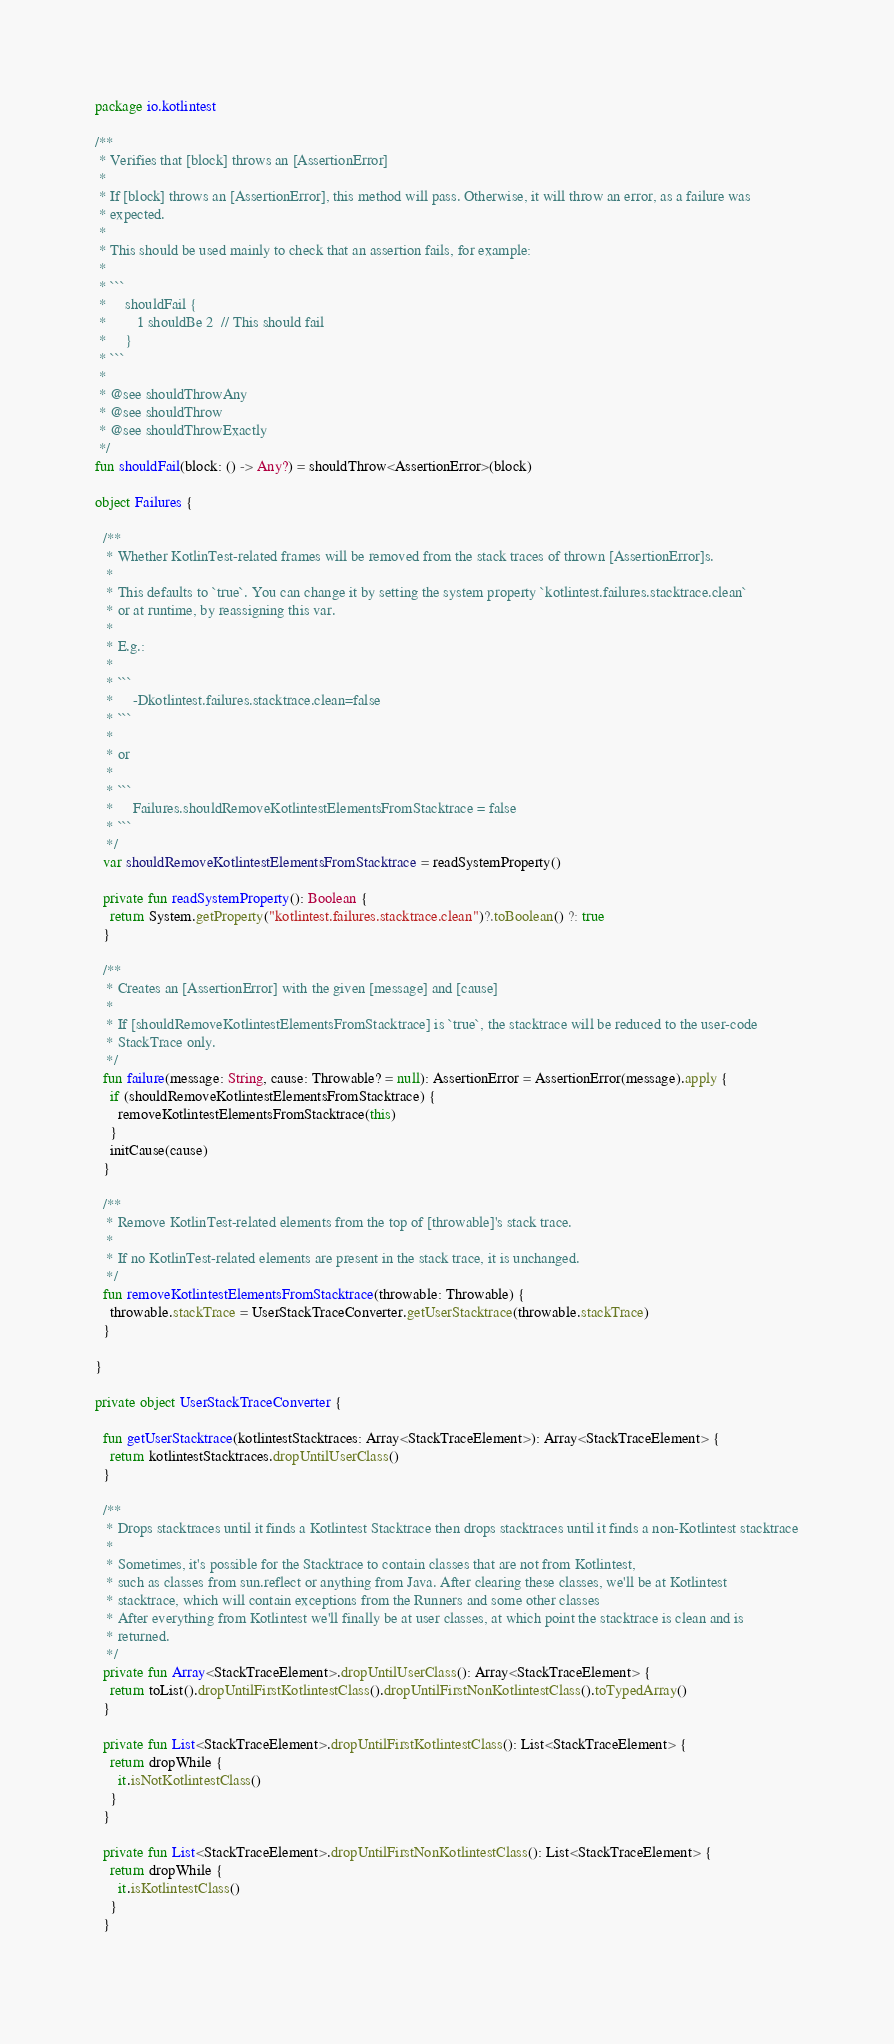<code> <loc_0><loc_0><loc_500><loc_500><_Kotlin_>package io.kotlintest

/**
 * Verifies that [block] throws an [AssertionError]
 *
 * If [block] throws an [AssertionError], this method will pass. Otherwise, it will throw an error, as a failure was
 * expected.
 *
 * This should be used mainly to check that an assertion fails, for example:
 *
 * ```
 *     shouldFail {
 *        1 shouldBe 2  // This should fail
 *     }
 * ```
 *
 * @see shouldThrowAny
 * @see shouldThrow
 * @see shouldThrowExactly
 */
fun shouldFail(block: () -> Any?) = shouldThrow<AssertionError>(block)

object Failures {

  /**
   * Whether KotlinTest-related frames will be removed from the stack traces of thrown [AssertionError]s.
   *
   * This defaults to `true`. You can change it by setting the system property `kotlintest.failures.stacktrace.clean`
   * or at runtime, by reassigning this var.
   *
   * E.g.:
   *
   * ```
   *     -Dkotlintest.failures.stacktrace.clean=false
   * ```
   *
   * or
   *
   * ```
   *     Failures.shouldRemoveKotlintestElementsFromStacktrace = false
   * ```
   */
  var shouldRemoveKotlintestElementsFromStacktrace = readSystemProperty()
  
  private fun readSystemProperty(): Boolean {
    return System.getProperty("kotlintest.failures.stacktrace.clean")?.toBoolean() ?: true
  }

  /**
   * Creates an [AssertionError] with the given [message] and [cause]
   *
   * If [shouldRemoveKotlintestElementsFromStacktrace] is `true`, the stacktrace will be reduced to the user-code
   * StackTrace only.
   */
  fun failure(message: String, cause: Throwable? = null): AssertionError = AssertionError(message).apply {
    if (shouldRemoveKotlintestElementsFromStacktrace) {
      removeKotlintestElementsFromStacktrace(this)
    }
    initCause(cause)
  }

  /**
   * Remove KotlinTest-related elements from the top of [throwable]'s stack trace.
   *
   * If no KotlinTest-related elements are present in the stack trace, it is unchanged.
   */
  fun removeKotlintestElementsFromStacktrace(throwable: Throwable) {
    throwable.stackTrace = UserStackTraceConverter.getUserStacktrace(throwable.stackTrace)
  }
  
}

private object UserStackTraceConverter {
  
  fun getUserStacktrace(kotlintestStacktraces: Array<StackTraceElement>): Array<StackTraceElement> {
    return kotlintestStacktraces.dropUntilUserClass()
  }
  
  /**
   * Drops stacktraces until it finds a Kotlintest Stacktrace then drops stacktraces until it finds a non-Kotlintest stacktrace
   *
   * Sometimes, it's possible for the Stacktrace to contain classes that are not from Kotlintest,
   * such as classes from sun.reflect or anything from Java. After clearing these classes, we'll be at Kotlintest
   * stacktrace, which will contain exceptions from the Runners and some other classes
   * After everything from Kotlintest we'll finally be at user classes, at which point the stacktrace is clean and is
   * returned.
   */
  private fun Array<StackTraceElement>.dropUntilUserClass(): Array<StackTraceElement> {
    return toList().dropUntilFirstKotlintestClass().dropUntilFirstNonKotlintestClass().toTypedArray()
  }
  
  private fun List<StackTraceElement>.dropUntilFirstKotlintestClass(): List<StackTraceElement> {
    return dropWhile {
      it.isNotKotlintestClass()
    }
  }
  
  private fun List<StackTraceElement>.dropUntilFirstNonKotlintestClass(): List<StackTraceElement> {
    return dropWhile {
      it.isKotlintestClass()
    }
  }
  </code> 